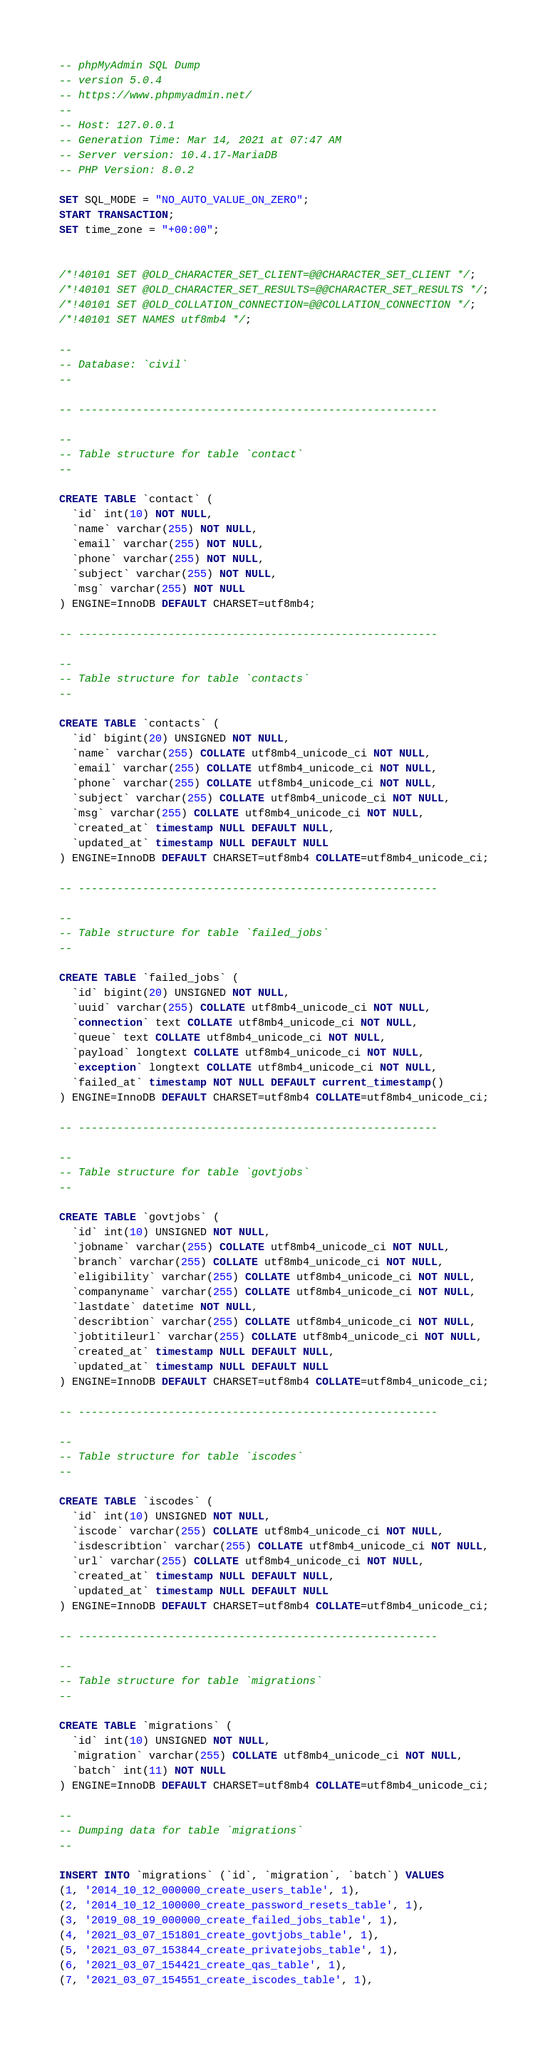Convert code to text. <code><loc_0><loc_0><loc_500><loc_500><_SQL_>-- phpMyAdmin SQL Dump
-- version 5.0.4
-- https://www.phpmyadmin.net/
--
-- Host: 127.0.0.1
-- Generation Time: Mar 14, 2021 at 07:47 AM
-- Server version: 10.4.17-MariaDB
-- PHP Version: 8.0.2

SET SQL_MODE = "NO_AUTO_VALUE_ON_ZERO";
START TRANSACTION;
SET time_zone = "+00:00";


/*!40101 SET @OLD_CHARACTER_SET_CLIENT=@@CHARACTER_SET_CLIENT */;
/*!40101 SET @OLD_CHARACTER_SET_RESULTS=@@CHARACTER_SET_RESULTS */;
/*!40101 SET @OLD_COLLATION_CONNECTION=@@COLLATION_CONNECTION */;
/*!40101 SET NAMES utf8mb4 */;

--
-- Database: `civil`
--

-- --------------------------------------------------------

--
-- Table structure for table `contact`
--

CREATE TABLE `contact` (
  `id` int(10) NOT NULL,
  `name` varchar(255) NOT NULL,
  `email` varchar(255) NOT NULL,
  `phone` varchar(255) NOT NULL,
  `subject` varchar(255) NOT NULL,
  `msg` varchar(255) NOT NULL
) ENGINE=InnoDB DEFAULT CHARSET=utf8mb4;

-- --------------------------------------------------------

--
-- Table structure for table `contacts`
--

CREATE TABLE `contacts` (
  `id` bigint(20) UNSIGNED NOT NULL,
  `name` varchar(255) COLLATE utf8mb4_unicode_ci NOT NULL,
  `email` varchar(255) COLLATE utf8mb4_unicode_ci NOT NULL,
  `phone` varchar(255) COLLATE utf8mb4_unicode_ci NOT NULL,
  `subject` varchar(255) COLLATE utf8mb4_unicode_ci NOT NULL,
  `msg` varchar(255) COLLATE utf8mb4_unicode_ci NOT NULL,
  `created_at` timestamp NULL DEFAULT NULL,
  `updated_at` timestamp NULL DEFAULT NULL
) ENGINE=InnoDB DEFAULT CHARSET=utf8mb4 COLLATE=utf8mb4_unicode_ci;

-- --------------------------------------------------------

--
-- Table structure for table `failed_jobs`
--

CREATE TABLE `failed_jobs` (
  `id` bigint(20) UNSIGNED NOT NULL,
  `uuid` varchar(255) COLLATE utf8mb4_unicode_ci NOT NULL,
  `connection` text COLLATE utf8mb4_unicode_ci NOT NULL,
  `queue` text COLLATE utf8mb4_unicode_ci NOT NULL,
  `payload` longtext COLLATE utf8mb4_unicode_ci NOT NULL,
  `exception` longtext COLLATE utf8mb4_unicode_ci NOT NULL,
  `failed_at` timestamp NOT NULL DEFAULT current_timestamp()
) ENGINE=InnoDB DEFAULT CHARSET=utf8mb4 COLLATE=utf8mb4_unicode_ci;

-- --------------------------------------------------------

--
-- Table structure for table `govtjobs`
--

CREATE TABLE `govtjobs` (
  `id` int(10) UNSIGNED NOT NULL,
  `jobname` varchar(255) COLLATE utf8mb4_unicode_ci NOT NULL,
  `branch` varchar(255) COLLATE utf8mb4_unicode_ci NOT NULL,
  `eligibility` varchar(255) COLLATE utf8mb4_unicode_ci NOT NULL,
  `companyname` varchar(255) COLLATE utf8mb4_unicode_ci NOT NULL,
  `lastdate` datetime NOT NULL,
  `describtion` varchar(255) COLLATE utf8mb4_unicode_ci NOT NULL,
  `jobtitileurl` varchar(255) COLLATE utf8mb4_unicode_ci NOT NULL,
  `created_at` timestamp NULL DEFAULT NULL,
  `updated_at` timestamp NULL DEFAULT NULL
) ENGINE=InnoDB DEFAULT CHARSET=utf8mb4 COLLATE=utf8mb4_unicode_ci;

-- --------------------------------------------------------

--
-- Table structure for table `iscodes`
--

CREATE TABLE `iscodes` (
  `id` int(10) UNSIGNED NOT NULL,
  `iscode` varchar(255) COLLATE utf8mb4_unicode_ci NOT NULL,
  `isdescribtion` varchar(255) COLLATE utf8mb4_unicode_ci NOT NULL,
  `url` varchar(255) COLLATE utf8mb4_unicode_ci NOT NULL,
  `created_at` timestamp NULL DEFAULT NULL,
  `updated_at` timestamp NULL DEFAULT NULL
) ENGINE=InnoDB DEFAULT CHARSET=utf8mb4 COLLATE=utf8mb4_unicode_ci;

-- --------------------------------------------------------

--
-- Table structure for table `migrations`
--

CREATE TABLE `migrations` (
  `id` int(10) UNSIGNED NOT NULL,
  `migration` varchar(255) COLLATE utf8mb4_unicode_ci NOT NULL,
  `batch` int(11) NOT NULL
) ENGINE=InnoDB DEFAULT CHARSET=utf8mb4 COLLATE=utf8mb4_unicode_ci;

--
-- Dumping data for table `migrations`
--

INSERT INTO `migrations` (`id`, `migration`, `batch`) VALUES
(1, '2014_10_12_000000_create_users_table', 1),
(2, '2014_10_12_100000_create_password_resets_table', 1),
(3, '2019_08_19_000000_create_failed_jobs_table', 1),
(4, '2021_03_07_151801_create_govtjobs_table', 1),
(5, '2021_03_07_153844_create_privatejobs_table', 1),
(6, '2021_03_07_154421_create_qas_table', 1),
(7, '2021_03_07_154551_create_iscodes_table', 1),</code> 